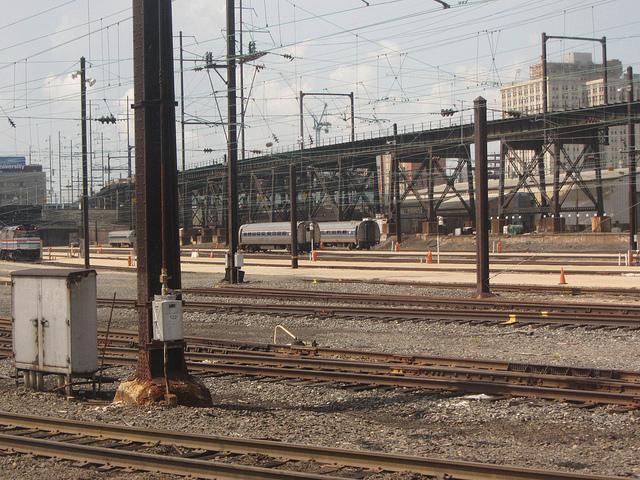What mode of transport is in the picture above?
Select the accurate answer and provide justification: `Answer: choice
Rationale: srationale.`
Options: Road, water, air, railway. Answer: railway.
Rationale: There is both visibly trains and rails which are associated with the manner of travel in answer a. 